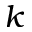Convert formula to latex. <formula><loc_0><loc_0><loc_500><loc_500>k</formula> 